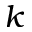Convert formula to latex. <formula><loc_0><loc_0><loc_500><loc_500>k</formula> 